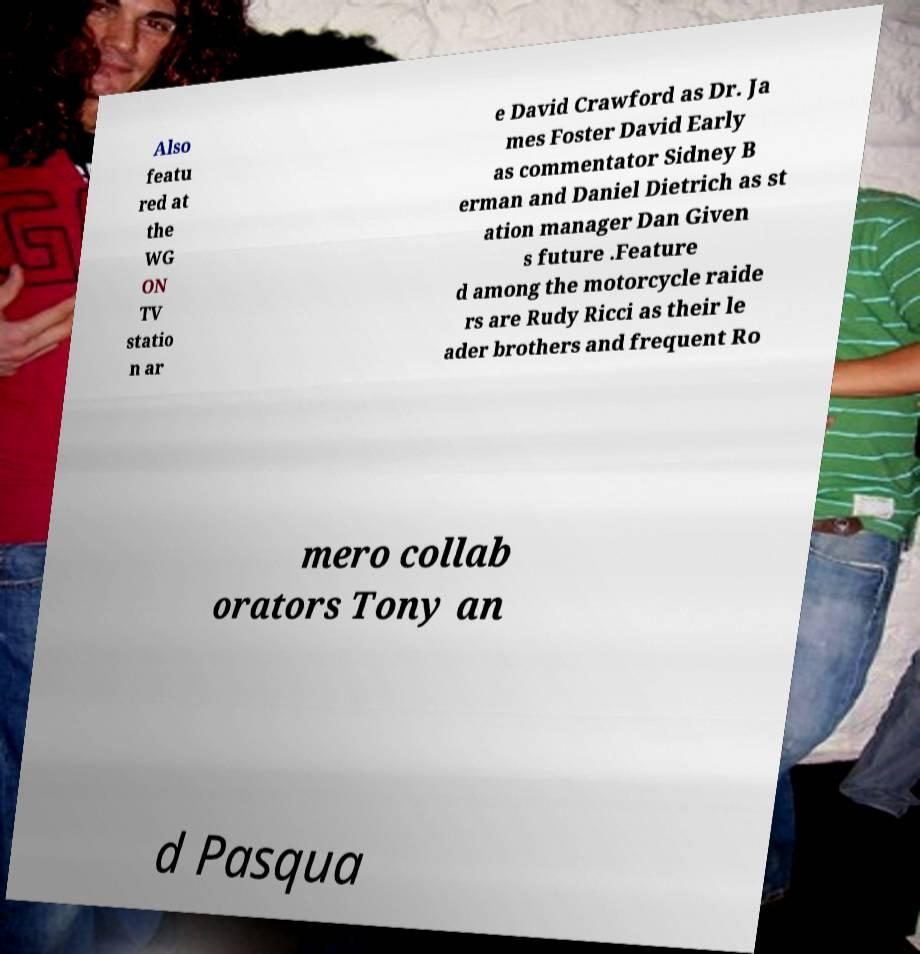I need the written content from this picture converted into text. Can you do that? Also featu red at the WG ON TV statio n ar e David Crawford as Dr. Ja mes Foster David Early as commentator Sidney B erman and Daniel Dietrich as st ation manager Dan Given s future .Feature d among the motorcycle raide rs are Rudy Ricci as their le ader brothers and frequent Ro mero collab orators Tony an d Pasqua 